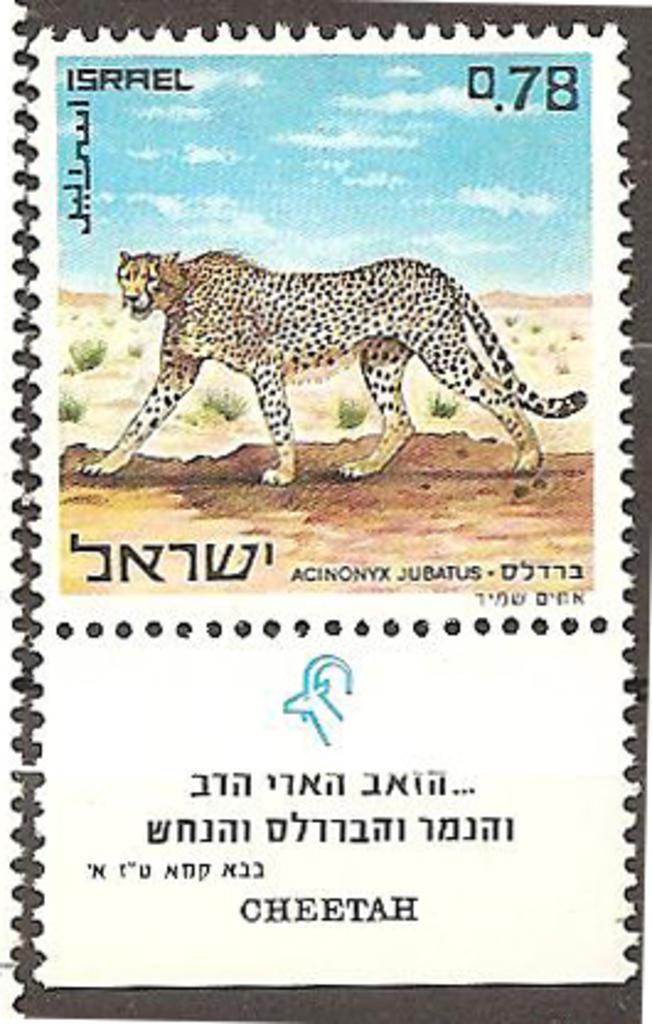How would you summarize this image in a sentence or two? As we can see in the image there is a poster. On poster there is a chitha and sky. 